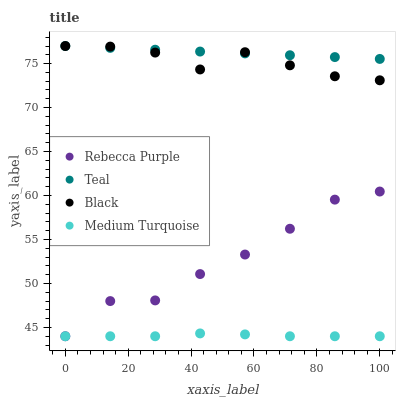Does Medium Turquoise have the minimum area under the curve?
Answer yes or no. Yes. Does Teal have the maximum area under the curve?
Answer yes or no. Yes. Does Black have the minimum area under the curve?
Answer yes or no. No. Does Black have the maximum area under the curve?
Answer yes or no. No. Is Teal the smoothest?
Answer yes or no. Yes. Is Rebecca Purple the roughest?
Answer yes or no. Yes. Is Black the smoothest?
Answer yes or no. No. Is Black the roughest?
Answer yes or no. No. Does Medium Turquoise have the lowest value?
Answer yes or no. Yes. Does Black have the lowest value?
Answer yes or no. No. Does Teal have the highest value?
Answer yes or no. Yes. Does Rebecca Purple have the highest value?
Answer yes or no. No. Is Medium Turquoise less than Black?
Answer yes or no. Yes. Is Black greater than Medium Turquoise?
Answer yes or no. Yes. Does Teal intersect Black?
Answer yes or no. Yes. Is Teal less than Black?
Answer yes or no. No. Is Teal greater than Black?
Answer yes or no. No. Does Medium Turquoise intersect Black?
Answer yes or no. No. 